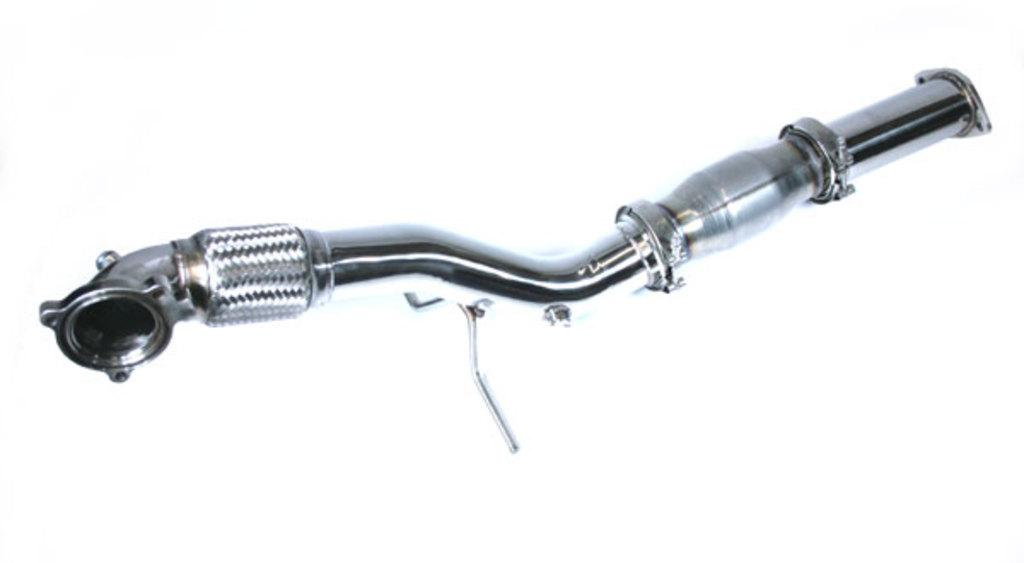What is the main object in the image? There is a steel pipe in the image. What color is the background of the image? The background of the image is white. What type of poison is being stored in the steel pipe in the image? There is no indication of any poison or substance being stored in the steel pipe in the image. 